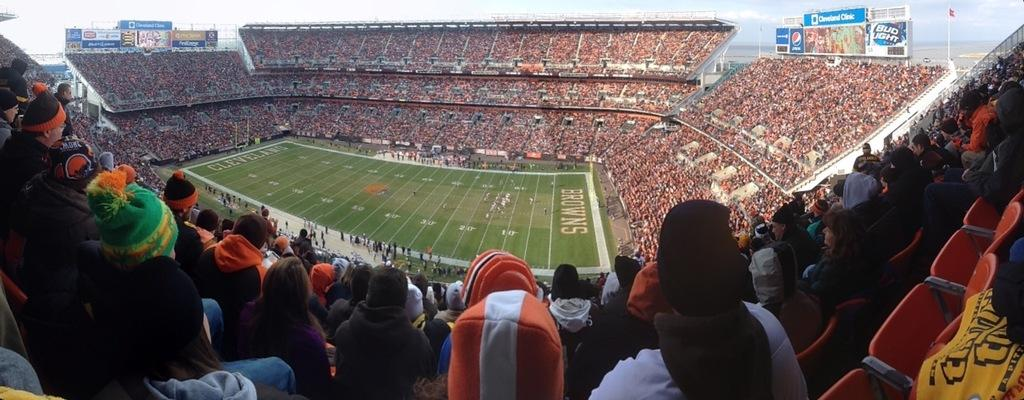What is the main subject in the foreground of the image? There is a playground in the foreground of the image. How are the people positioned in relation to the playground? The people are surrounding the playground on all four sides. Where are the empty chairs located in the image? The empty chairs are in the right bottom corner of the image. Is the crib in motion in the image? There is no crib present in the image. 